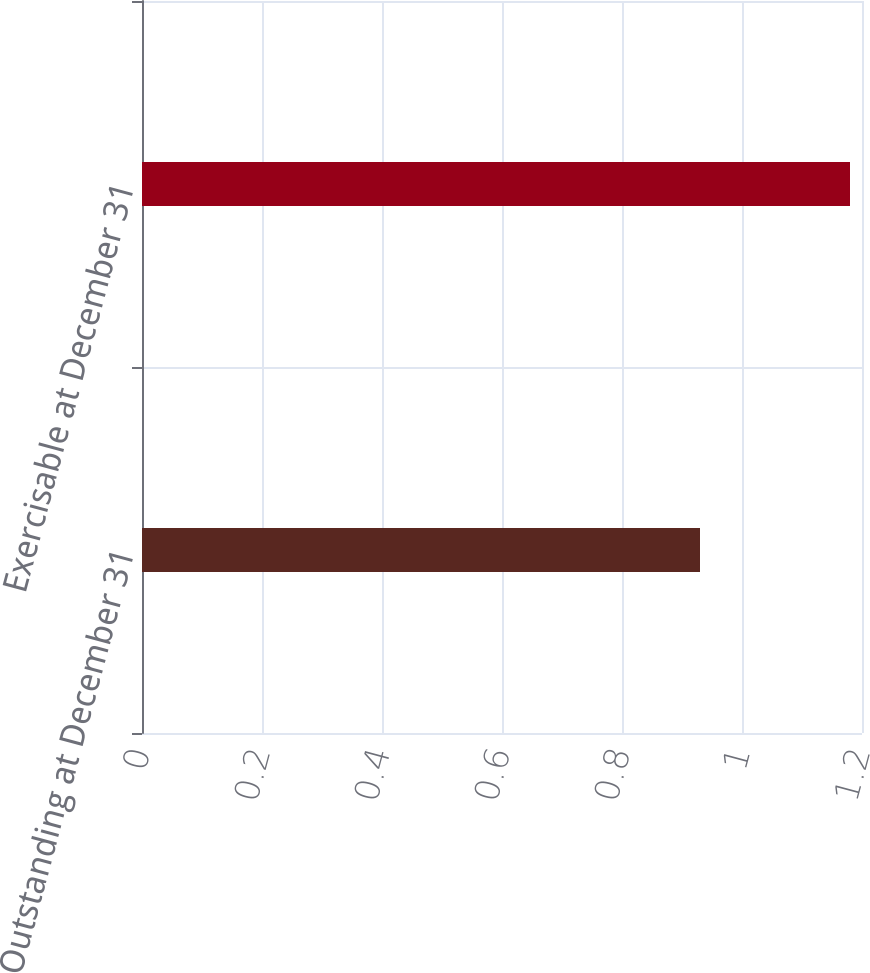Convert chart to OTSL. <chart><loc_0><loc_0><loc_500><loc_500><bar_chart><fcel>Outstanding at December 31<fcel>Exercisable at December 31<nl><fcel>0.93<fcel>1.18<nl></chart> 